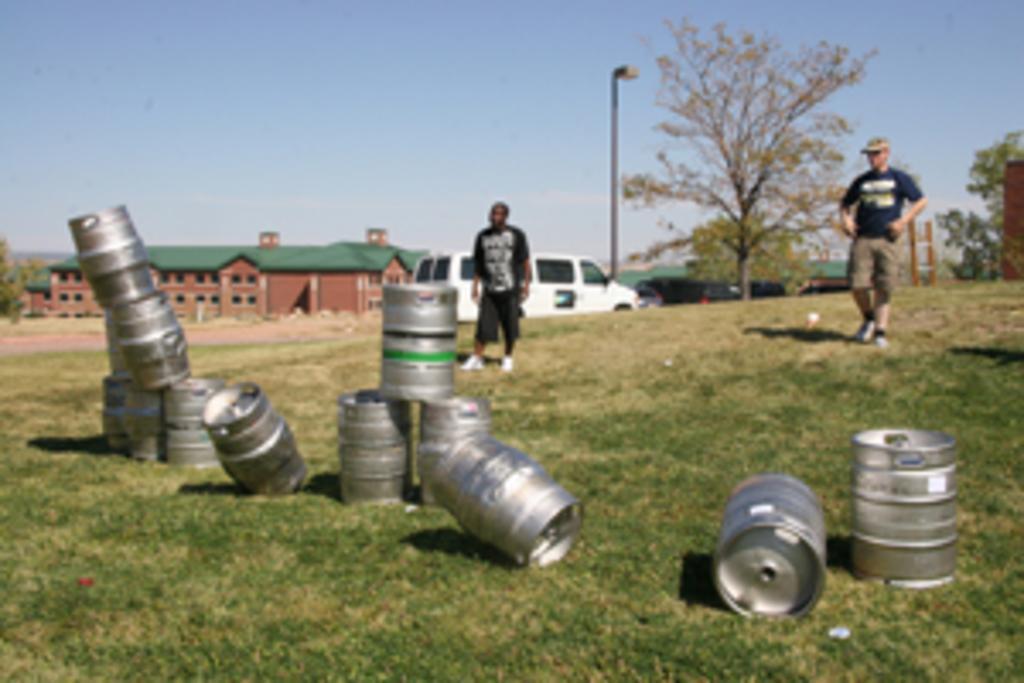Can you describe this image briefly? In front of the picture, we see large silver tins. At the bottom of the picture, we see grass. Behind that, we see two men are standing. There are trees, pole and a building in the background. At the top of the picture, we see the sky. 